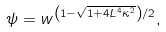<formula> <loc_0><loc_0><loc_500><loc_500>\psi = w ^ { \left ( 1 - \sqrt { 1 + 4 L ^ { 4 } \kappa ^ { 2 } } \right ) / 2 } ,</formula> 